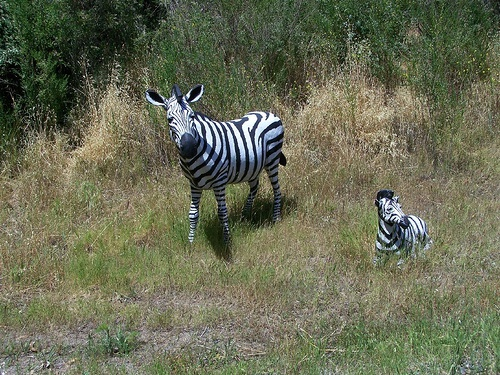Describe the objects in this image and their specific colors. I can see zebra in teal, black, gray, white, and navy tones and zebra in teal, gray, black, white, and darkgray tones in this image. 